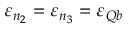Convert formula to latex. <formula><loc_0><loc_0><loc_500><loc_500>\varepsilon _ { n _ { 2 } } = \varepsilon _ { n _ { 3 } } = \varepsilon _ { Q b }</formula> 